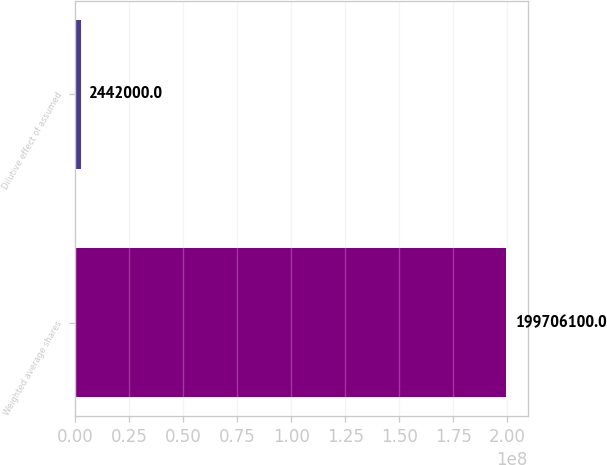Convert chart to OTSL. <chart><loc_0><loc_0><loc_500><loc_500><bar_chart><fcel>Weighted average shares<fcel>Dilutive effect of assumed<nl><fcel>1.99706e+08<fcel>2.442e+06<nl></chart> 